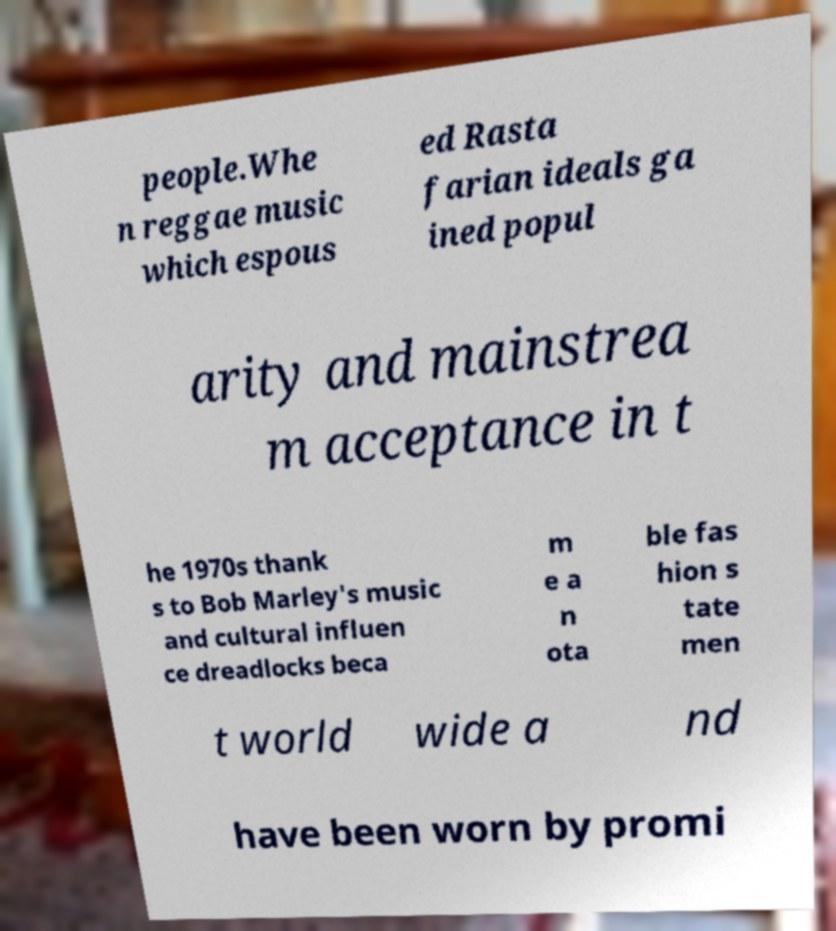Please identify and transcribe the text found in this image. people.Whe n reggae music which espous ed Rasta farian ideals ga ined popul arity and mainstrea m acceptance in t he 1970s thank s to Bob Marley's music and cultural influen ce dreadlocks beca m e a n ota ble fas hion s tate men t world wide a nd have been worn by promi 